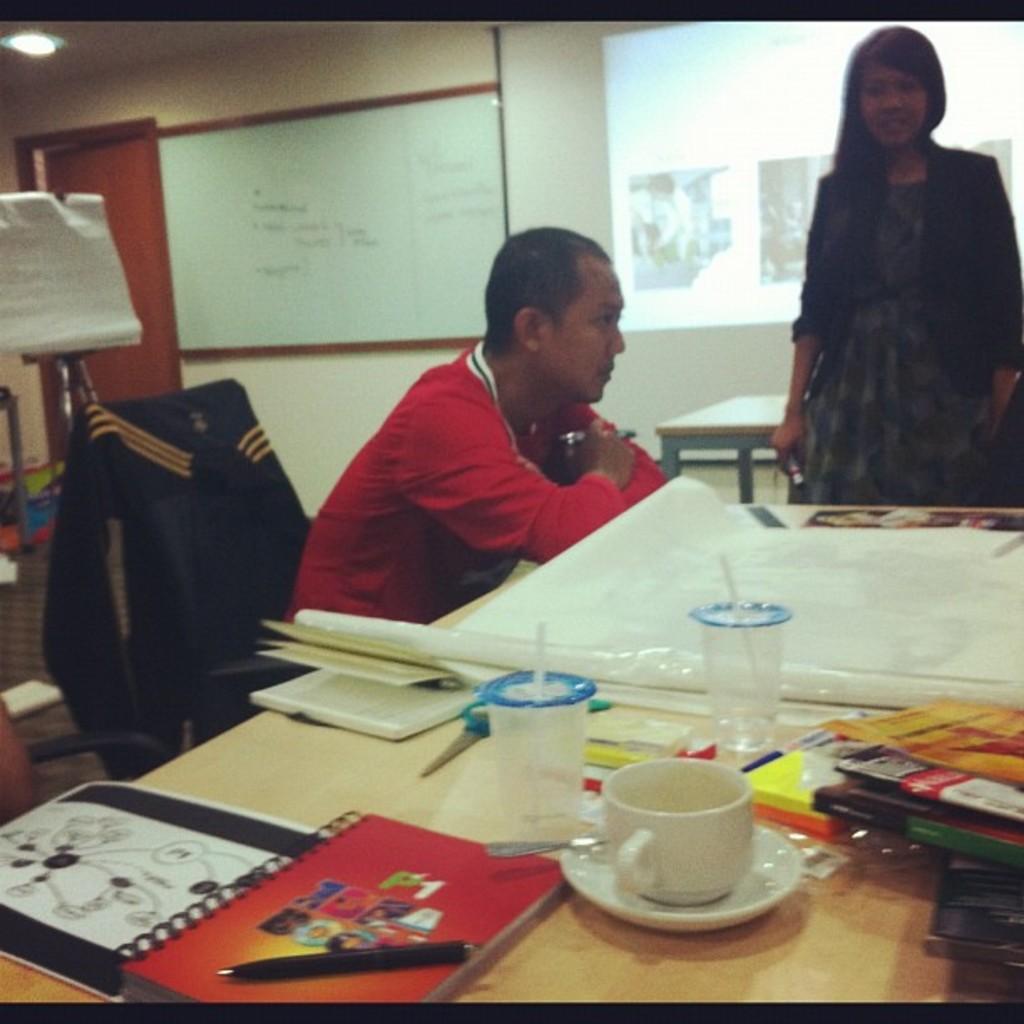How would you summarize this image in a sentence or two? In this picture we see a man seated on the chair and we see a woman standing in front of them there is a table, on the table we can see books, tea cups and on the wall we can see a notice board. 